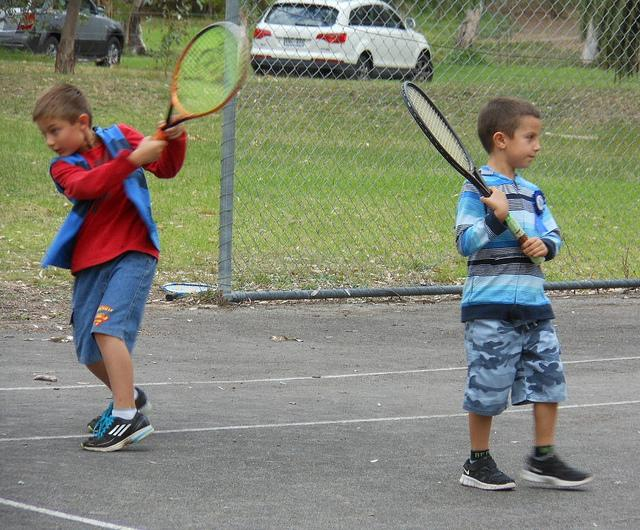What is the first name of the boy in the red's favorite hero? Please explain your reasoning. clark. The logo for 'superman' is visible on the boy in red's jean shorts. clark kent is the name of superman's alter ego. 